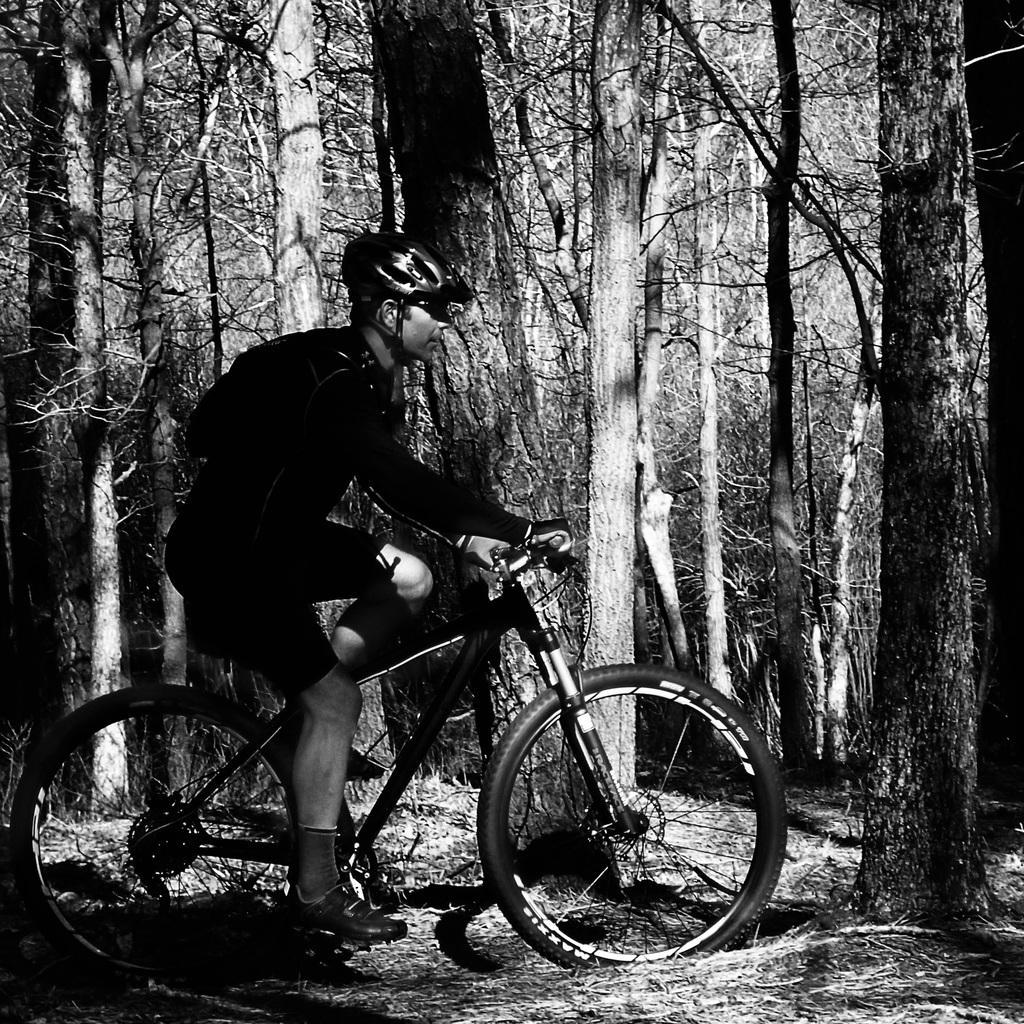Describe this image in one or two sentences. The image looks like it is clicked in a deep forest. There is a man riding bicycle, wearing helmet and sports dress. In the background there are many trees. At the bottom there is a dry grass. 